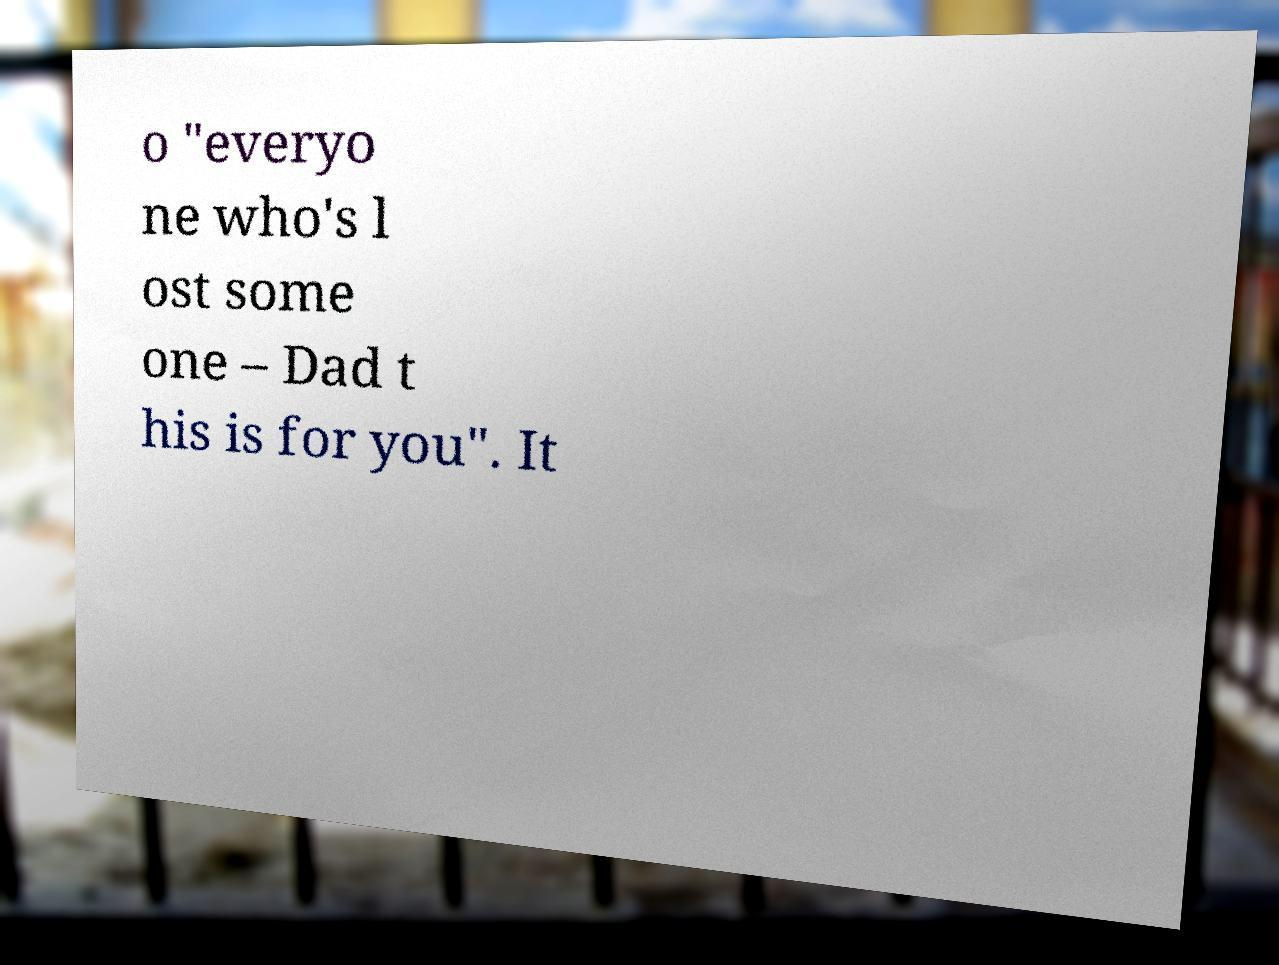For documentation purposes, I need the text within this image transcribed. Could you provide that? o "everyo ne who's l ost some one – Dad t his is for you". It 